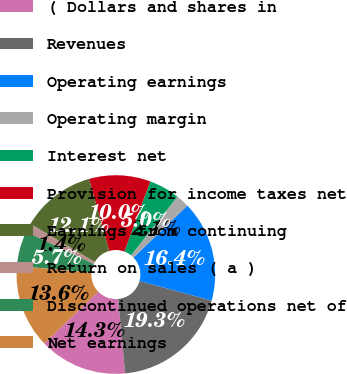Convert chart. <chart><loc_0><loc_0><loc_500><loc_500><pie_chart><fcel>( Dollars and shares in<fcel>Revenues<fcel>Operating earnings<fcel>Operating margin<fcel>Interest net<fcel>Provision for income taxes net<fcel>Earnings from continuing<fcel>Return on sales ( a )<fcel>Discontinued operations net of<fcel>Net earnings<nl><fcel>14.29%<fcel>19.29%<fcel>16.43%<fcel>2.14%<fcel>5.0%<fcel>10.0%<fcel>12.14%<fcel>1.43%<fcel>5.71%<fcel>13.57%<nl></chart> 